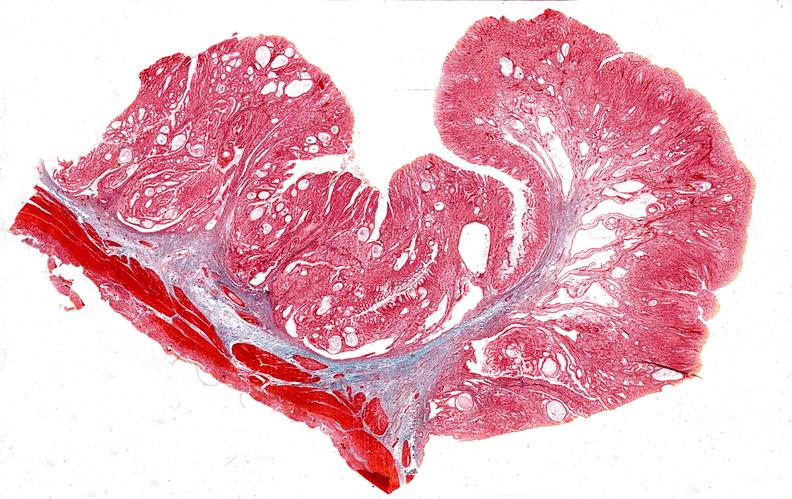what does this image show?
Answer the question using a single word or phrase. Stomach 